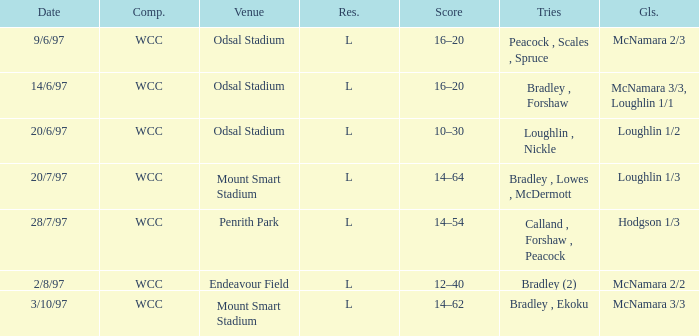Can you parse all the data within this table? {'header': ['Date', 'Comp.', 'Venue', 'Res.', 'Score', 'Tries', 'Gls.'], 'rows': [['9/6/97', 'WCC', 'Odsal Stadium', 'L', '16–20', 'Peacock , Scales , Spruce', 'McNamara 2/3'], ['14/6/97', 'WCC', 'Odsal Stadium', 'L', '16–20', 'Bradley , Forshaw', 'McNamara 3/3, Loughlin 1/1'], ['20/6/97', 'WCC', 'Odsal Stadium', 'L', '10–30', 'Loughlin , Nickle', 'Loughlin 1/2'], ['20/7/97', 'WCC', 'Mount Smart Stadium', 'L', '14–64', 'Bradley , Lowes , McDermott', 'Loughlin 1/3'], ['28/7/97', 'WCC', 'Penrith Park', 'L', '14–54', 'Calland , Forshaw , Peacock', 'Hodgson 1/3'], ['2/8/97', 'WCC', 'Endeavour Field', 'L', '12–40', 'Bradley (2)', 'McNamara 2/2'], ['3/10/97', 'WCC', 'Mount Smart Stadium', 'L', '14–62', 'Bradley , Ekoku', 'McNamara 3/3']]} What was the score on 20/6/97? 10–30. 